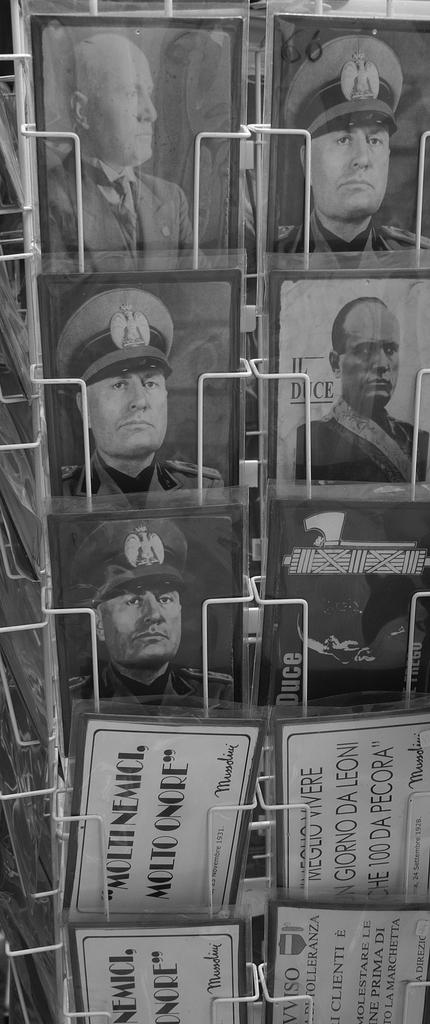<image>
Render a clear and concise summary of the photo. black and white post cards of military men including Il Duce 